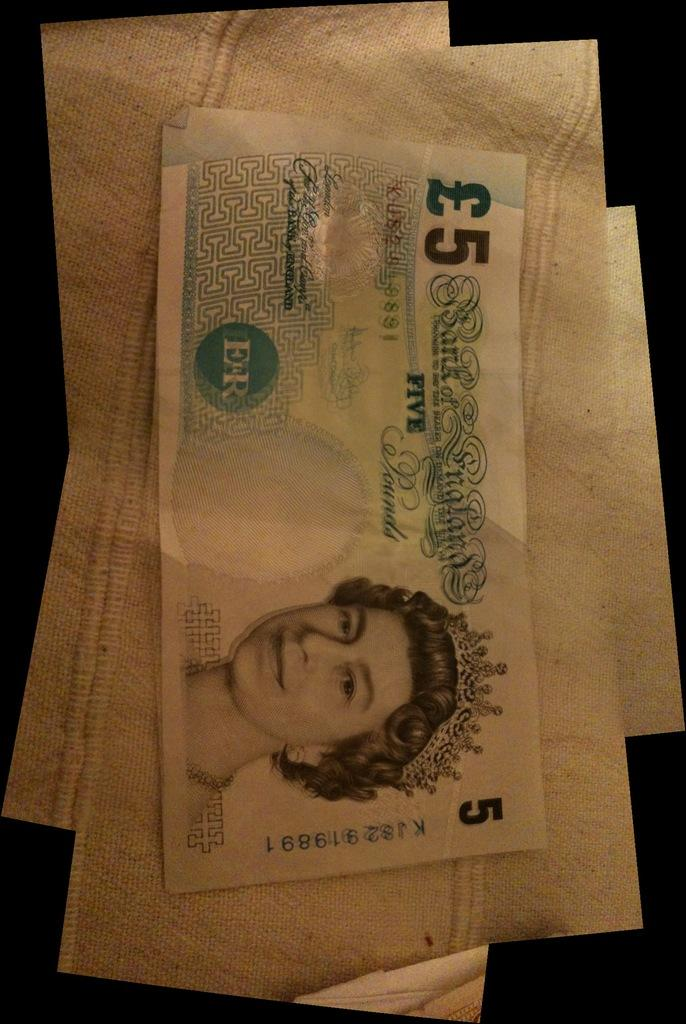What can be seen on the walls in the image? There are posters in the image. What type of object related to money can be seen in the image? There is a currency in the image. How many friends are visible in the image? There is no reference to friends in the image, so it is not possible to answer that question. What type of bird can be seen flying in the image? There is no bird present in the image. 